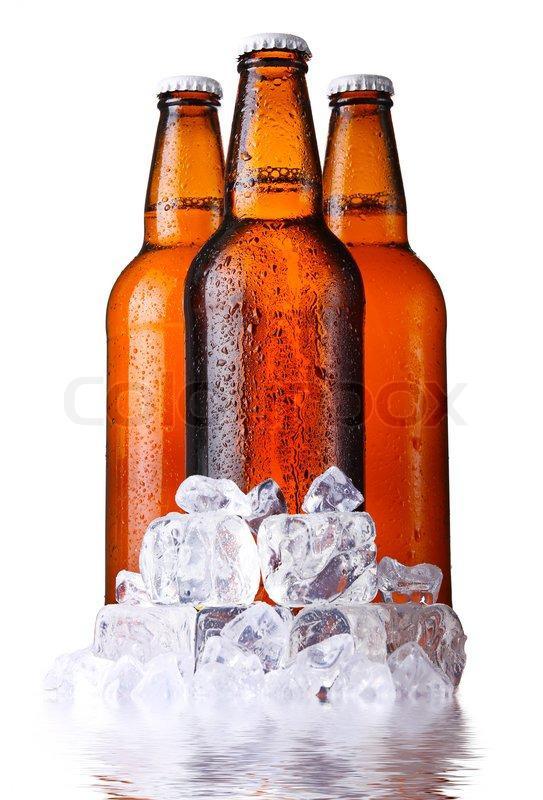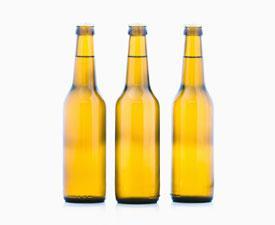The first image is the image on the left, the second image is the image on the right. Examine the images to the left and right. Is the description "All bottles are shown in groups of three and are capped." accurate? Answer yes or no. Yes. The first image is the image on the left, the second image is the image on the right. For the images shown, is this caption "One set of bottles is yellow and the other set is more brown." true? Answer yes or no. Yes. 